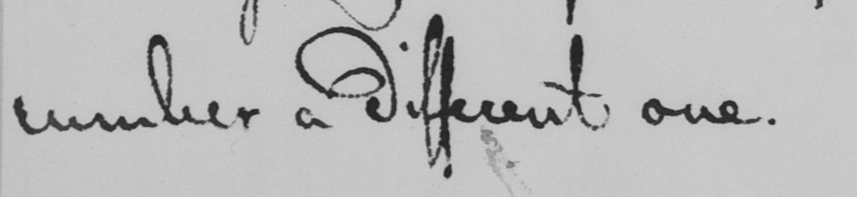What is written in this line of handwriting? number a different one . 